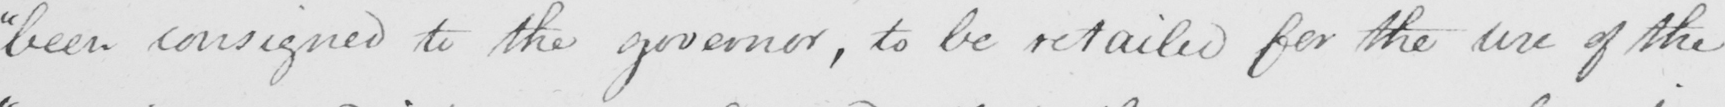Transcribe the text shown in this historical manuscript line. " been consigned to the governor , to be retailed for the use of the 